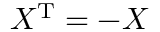<formula> <loc_0><loc_0><loc_500><loc_500>X ^ { T } = - X</formula> 